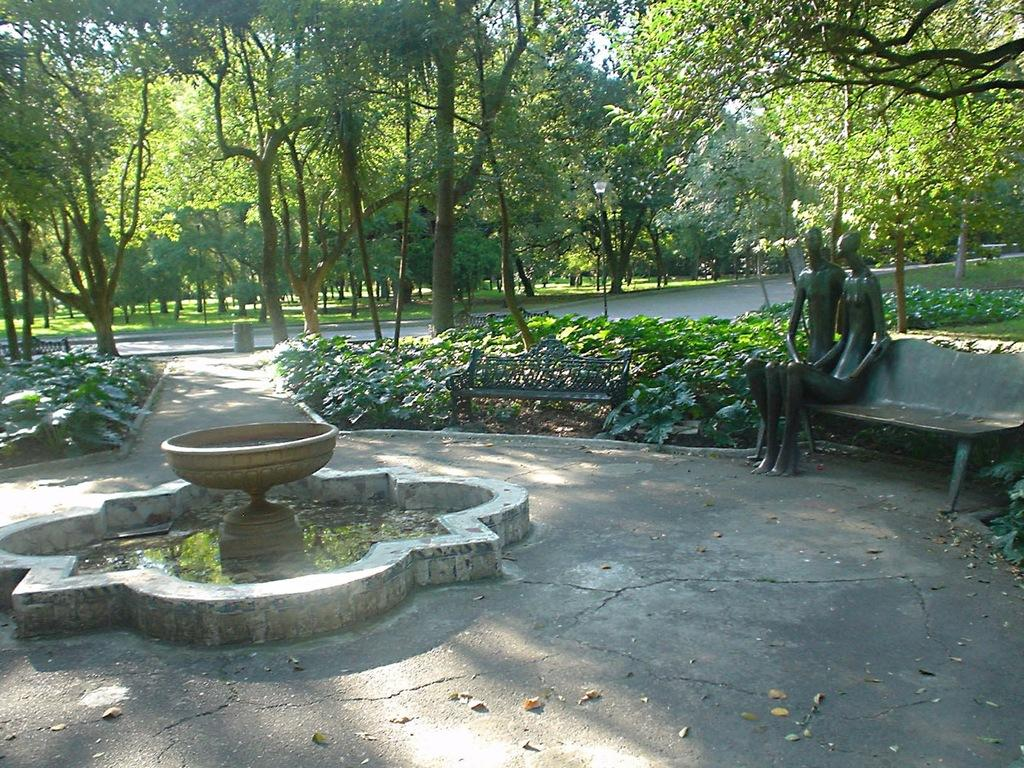What is located in the foreground of the image? There is a fountain and sculptures in the foreground of the image. What type of vegetation can be seen in the background of the image? There are trees in the background of the image. What is the natural landscape visible in the background of the image? There is grassland in the background of the image. What part of the natural environment is visible in the background of the image? The sky is visible in the background of the image. What type of quill can be seen in the image? There is no quill present in the image. How many dimes are visible on the sculptures in the image? There are no dimes visible on the sculptures in the image. 